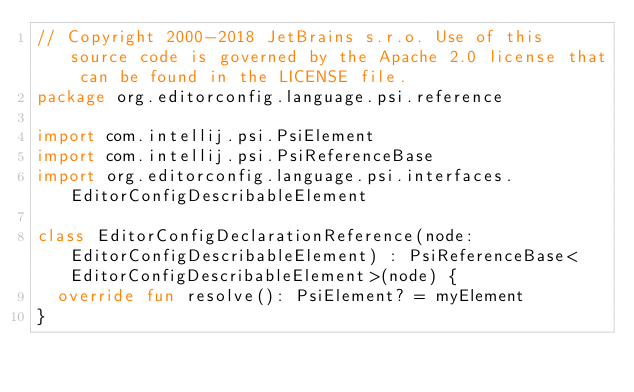Convert code to text. <code><loc_0><loc_0><loc_500><loc_500><_Kotlin_>// Copyright 2000-2018 JetBrains s.r.o. Use of this source code is governed by the Apache 2.0 license that can be found in the LICENSE file.
package org.editorconfig.language.psi.reference

import com.intellij.psi.PsiElement
import com.intellij.psi.PsiReferenceBase
import org.editorconfig.language.psi.interfaces.EditorConfigDescribableElement

class EditorConfigDeclarationReference(node: EditorConfigDescribableElement) : PsiReferenceBase<EditorConfigDescribableElement>(node) {
  override fun resolve(): PsiElement? = myElement
}
</code> 